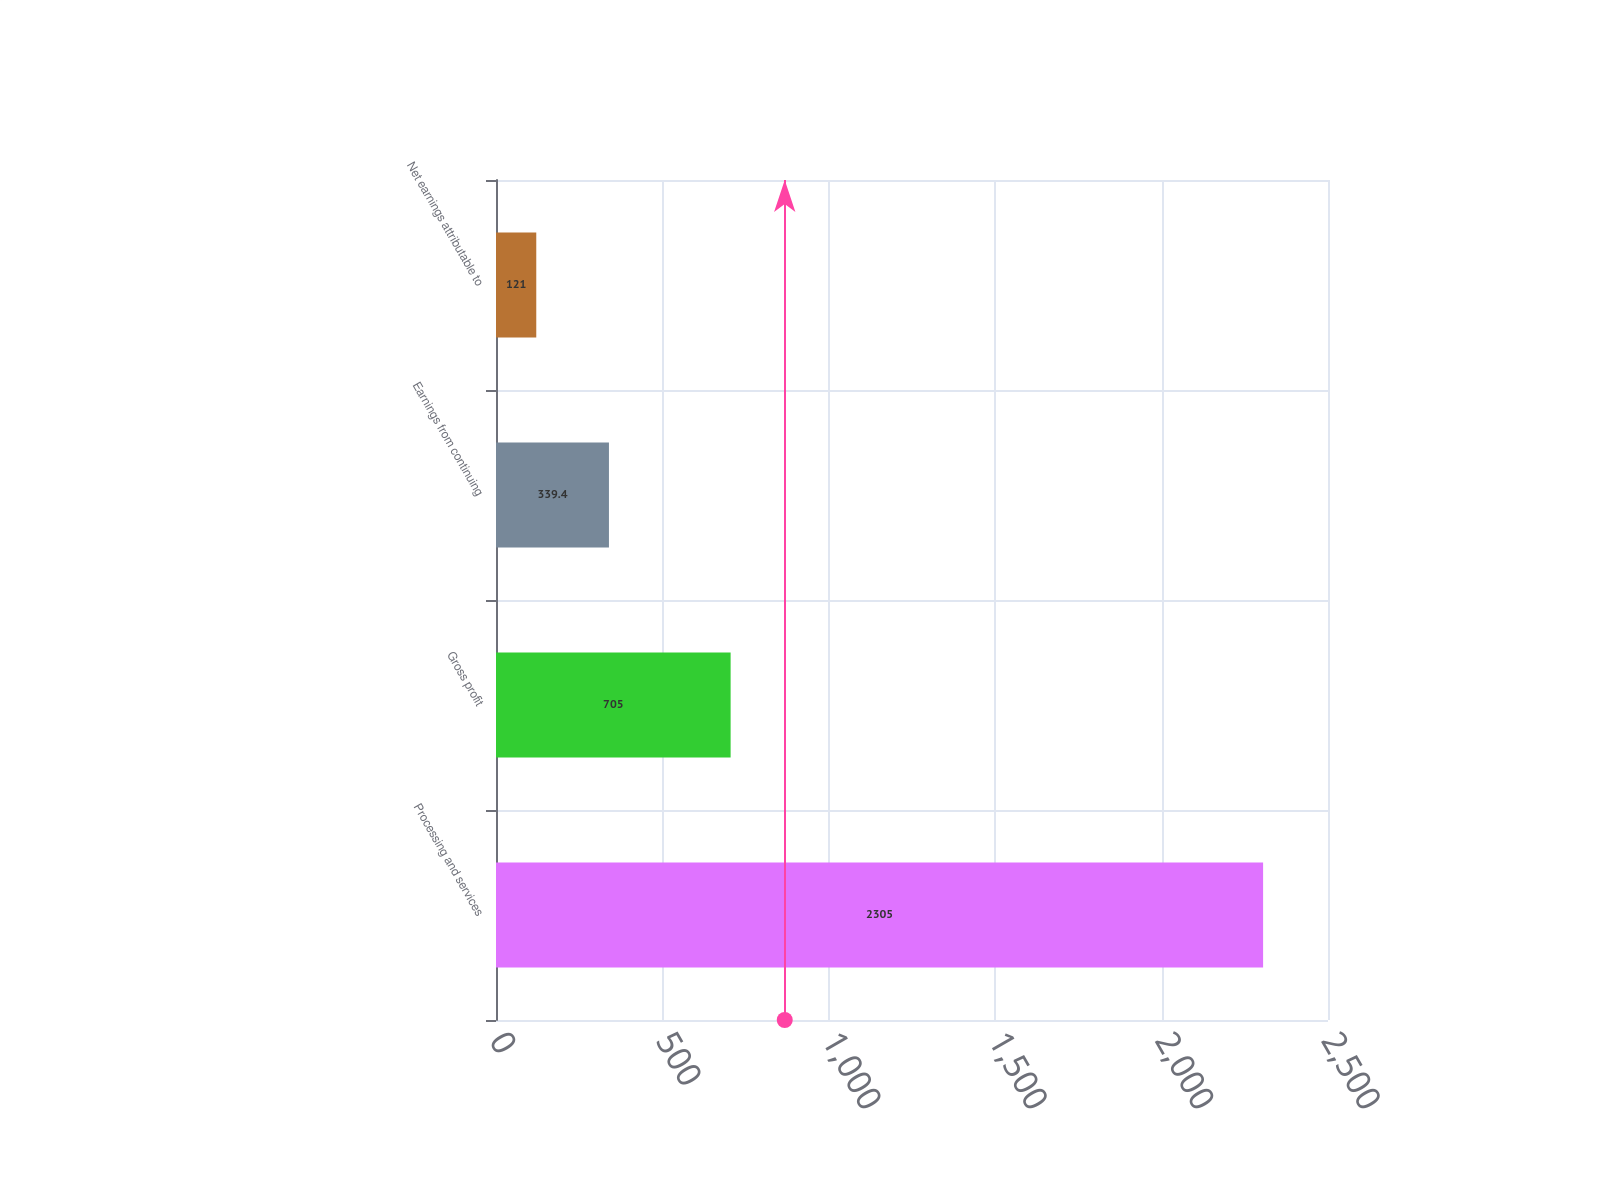<chart> <loc_0><loc_0><loc_500><loc_500><bar_chart><fcel>Processing and services<fcel>Gross profit<fcel>Earnings from continuing<fcel>Net earnings attributable to<nl><fcel>2305<fcel>705<fcel>339.4<fcel>121<nl></chart> 